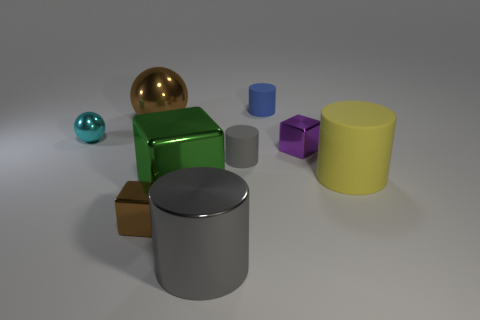Subtract all big gray cylinders. How many cylinders are left? 3 Add 1 large blue rubber balls. How many objects exist? 10 Subtract all green blocks. How many gray cylinders are left? 2 Subtract all gray cylinders. How many cylinders are left? 2 Subtract all spheres. How many objects are left? 7 Subtract all blue objects. Subtract all tiny cyan metallic spheres. How many objects are left? 7 Add 5 green things. How many green things are left? 6 Add 4 red metallic spheres. How many red metallic spheres exist? 4 Subtract 0 blue cubes. How many objects are left? 9 Subtract 4 cylinders. How many cylinders are left? 0 